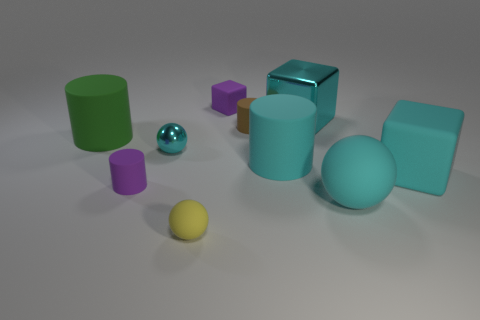Subtract all balls. How many objects are left? 7 Subtract all purple matte objects. Subtract all purple matte objects. How many objects are left? 6 Add 7 big cyan metallic things. How many big cyan metallic things are left? 8 Add 3 cyan cylinders. How many cyan cylinders exist? 4 Subtract 0 blue balls. How many objects are left? 10 